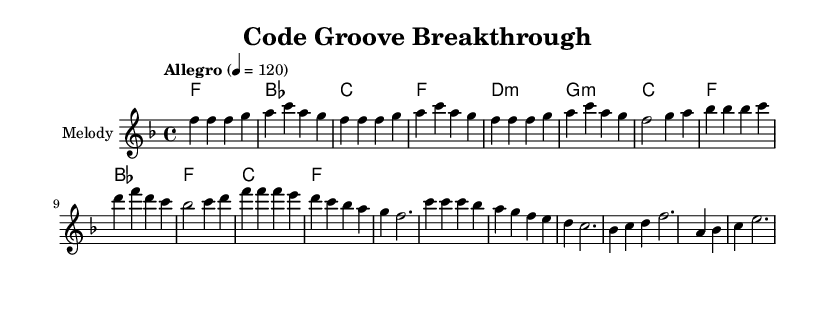What is the key signature of this music? The key signature indicates that the piece is in F major, which contains one flat (B flat). This can be identified by looking at the clef and the sharp/flat indicators on the staff at the beginning of the piece.
Answer: F major What is the time signature of this music? The time signature shown at the beginning is 4/4, meaning there are four beats in each measure and the quarter note gets one beat. This can be clearly seen next to the key signature.
Answer: 4/4 What is the tempo marking of this piece? The tempo marking states "Allegro" with a metronome mark of 120 beats per minute. This indicates a fast and lively pace. The tempo is located above the staff, beneath the title.
Answer: Allegro, 120 How many measures are there in the melody section? To find the total number of measures in the melody, we can count each segment in the melody line, separating by vertical bar lines. There are eight measures in the provided sections.
Answer: Eight Which chord is played at the beginning of the score? The score starts the chord progression with an F major chord. This can be found at the beginning of the harmonies section, where the first chord is listed.
Answer: F What are the last two chords in the chord progression? The last two chords in the chord progression are C major and F major. By looking at the harmonies section, we can identify these chords are listed at the end of the chord changes.
Answer: C, F What musical style does this piece represent? The piece represents the Soul genre, as indicated by the upbeat style and thematic elements related to coding breakthroughs and tech success. The title and context reflect the blend of musical style with subject matter.
Answer: Soul 